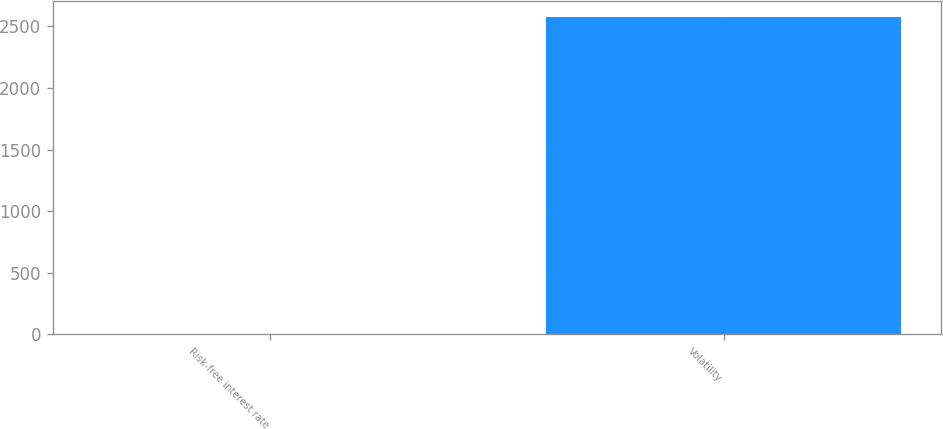<chart> <loc_0><loc_0><loc_500><loc_500><bar_chart><fcel>Risk-free interest rate<fcel>Volatility<nl><fcel>1.11<fcel>2575<nl></chart> 